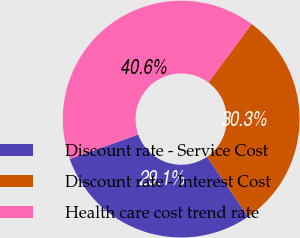Convert chart. <chart><loc_0><loc_0><loc_500><loc_500><pie_chart><fcel>Discount rate - Service Cost<fcel>Discount rate - Interest Cost<fcel>Health care cost trend rate<nl><fcel>29.11%<fcel>30.26%<fcel>40.62%<nl></chart> 